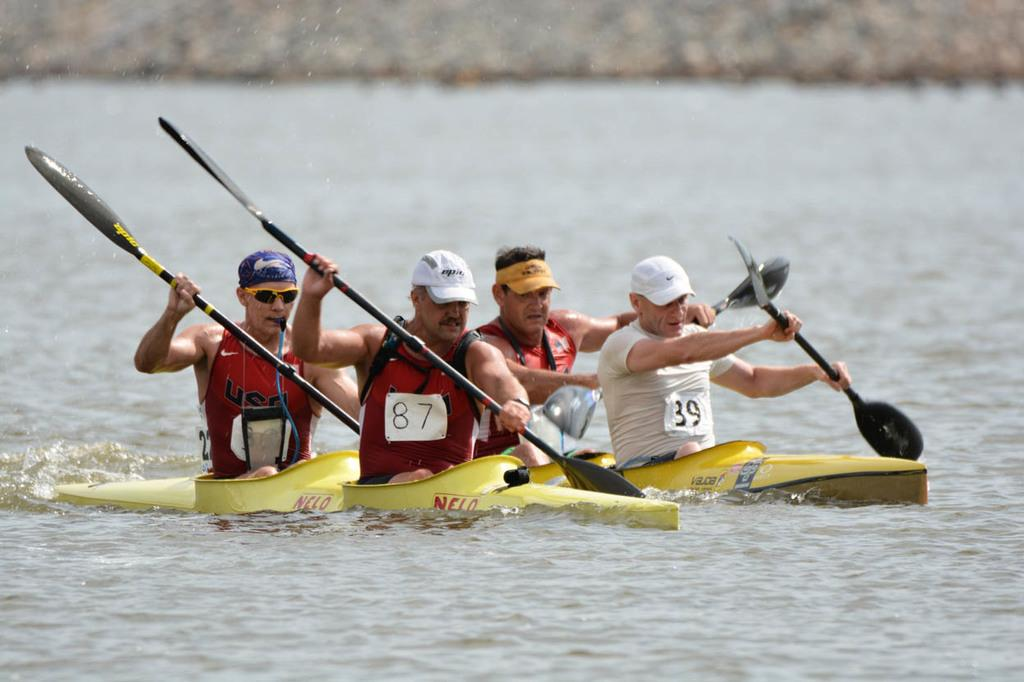What is the main element present in the image? There is water in the image. What are the people doing in the water? The people are sitting on a kayak in the water. What are the people holding in their hands? The people are holding paddles in their hands. Can you tell me how much cheese is present in the image? There is no cheese present in the image. What type of watch is the person wearing in the image? There is no watch visible in the image. 